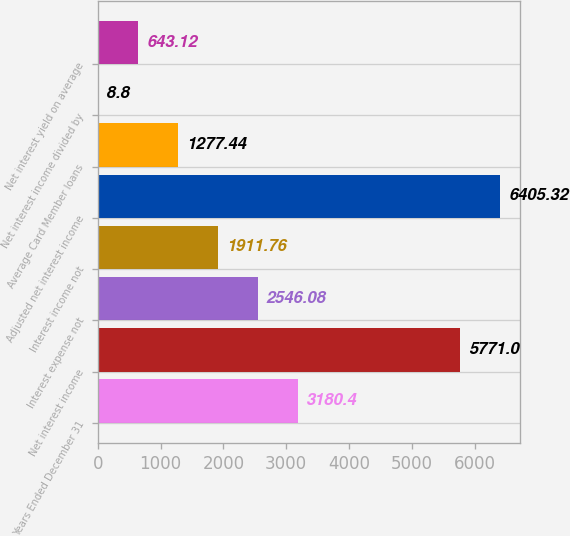Convert chart. <chart><loc_0><loc_0><loc_500><loc_500><bar_chart><fcel>Years Ended December 31<fcel>Net interest income<fcel>Interest expense not<fcel>Interest income not<fcel>Adjusted net interest income<fcel>Average Card Member loans<fcel>Net interest income divided by<fcel>Net interest yield on average<nl><fcel>3180.4<fcel>5771<fcel>2546.08<fcel>1911.76<fcel>6405.32<fcel>1277.44<fcel>8.8<fcel>643.12<nl></chart> 